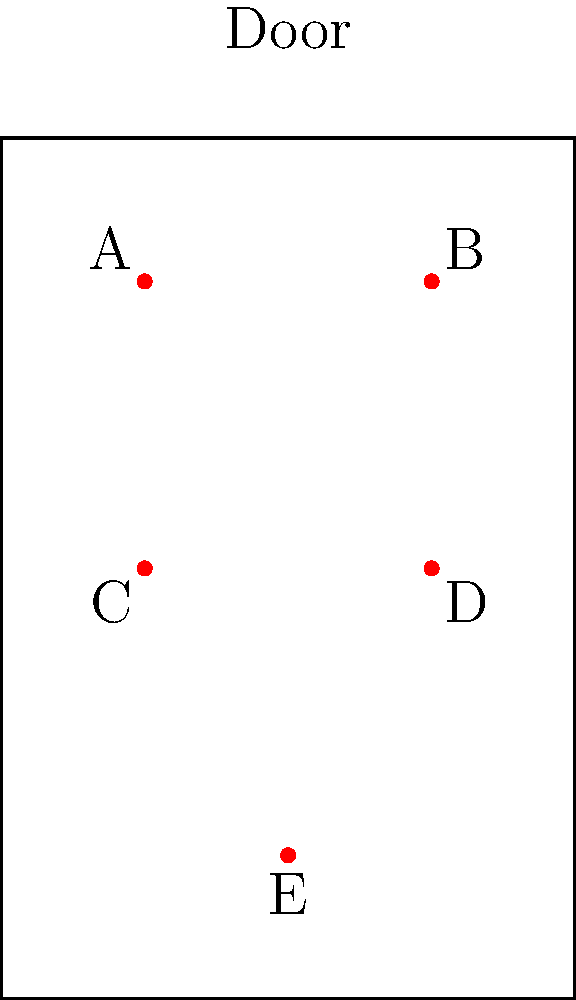Given a rectangular door with dimensions 4 units wide and 6 units tall, five locks (A, B, C, D, and E) are placed as shown in the diagram. What is the optimal configuration of three locks that maximizes the average distance between them, thereby increasing the difficulty for an intruder to compromise all locks simultaneously? To find the optimal configuration, we need to calculate the average distance between each possible combination of three locks and choose the one with the largest average distance. Here's how we can approach this:

1. List all possible combinations of three locks:
   ABC, ABD, ABE, ACD, ACE, ADE, BCD, BCE, BDE, CDE

2. Calculate the distance between each pair of locks in each combination using the distance formula: $d = \sqrt{(x_2-x_1)^2 + (y_2-y_1)^2}$

3. For each combination, calculate the average of the three distances between the locks.

4. Choose the combination with the largest average distance.

Let's calculate for a few key combinations:

ADE:
AD distance: $\sqrt{2^2 + 2^2} = 2\sqrt{2}$
AE distance: $\sqrt{1^2 + 4^2} = \sqrt{17}$
DE distance: $\sqrt{1^2 + 2^2} = \sqrt{5}$
Average: $\frac{2\sqrt{2} + \sqrt{17} + \sqrt{5}}{3} \approx 2.97$

ABE:
AB distance: 2
AE distance: $\sqrt{17}$
BE distance: $\sqrt{17}$
Average: $\frac{2 + 2\sqrt{17}}{3} \approx 3.08$

ACE:
AC distance: 2
AE distance: $\sqrt{17}$
CE distance: $\sqrt{13}$
Average: $\frac{2 + \sqrt{17} + \sqrt{13}}{3} \approx 3.19$

After calculating all combinations, we find that ACE has the largest average distance.
Answer: Locks A, C, and E 